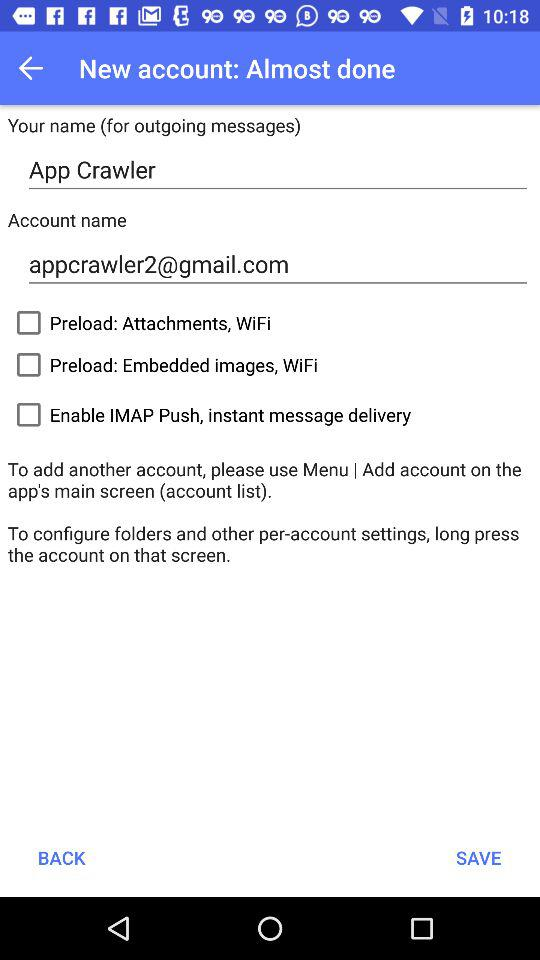What are the different options? The different options are "Preload: Attachments, WiFi", "Preload: Embedded images, WiFi" and "Enable IMAP Push, instant message delivery". 